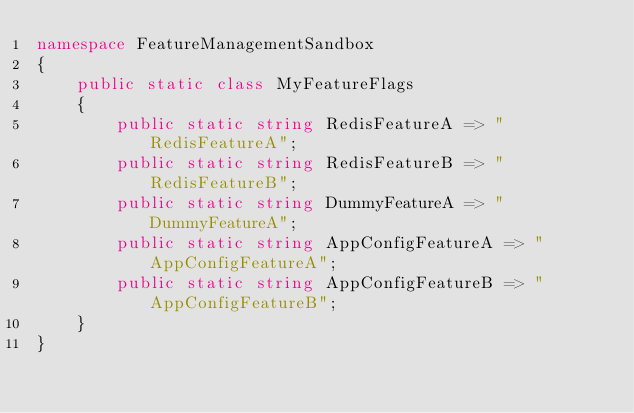Convert code to text. <code><loc_0><loc_0><loc_500><loc_500><_C#_>namespace FeatureManagementSandbox
{
    public static class MyFeatureFlags
    {
        public static string RedisFeatureA => "RedisFeatureA";
        public static string RedisFeatureB => "RedisFeatureB";
        public static string DummyFeatureA => "DummyFeatureA";
        public static string AppConfigFeatureA => "AppConfigFeatureA";
        public static string AppConfigFeatureB => "AppConfigFeatureB";
    }
}</code> 